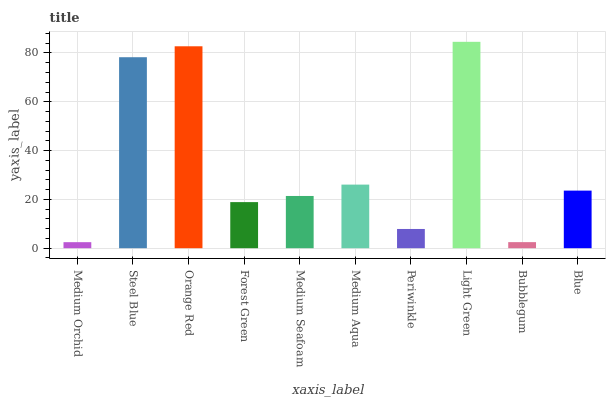Is Medium Orchid the minimum?
Answer yes or no. Yes. Is Light Green the maximum?
Answer yes or no. Yes. Is Steel Blue the minimum?
Answer yes or no. No. Is Steel Blue the maximum?
Answer yes or no. No. Is Steel Blue greater than Medium Orchid?
Answer yes or no. Yes. Is Medium Orchid less than Steel Blue?
Answer yes or no. Yes. Is Medium Orchid greater than Steel Blue?
Answer yes or no. No. Is Steel Blue less than Medium Orchid?
Answer yes or no. No. Is Blue the high median?
Answer yes or no. Yes. Is Medium Seafoam the low median?
Answer yes or no. Yes. Is Forest Green the high median?
Answer yes or no. No. Is Forest Green the low median?
Answer yes or no. No. 